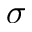<formula> <loc_0><loc_0><loc_500><loc_500>\sigma</formula> 